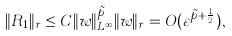Convert formula to latex. <formula><loc_0><loc_0><loc_500><loc_500>\| R _ { 1 } \| _ { \L r } \leq C \| w \| _ { L ^ { \infty } } ^ { \tilde { p } } \| w \| _ { \L r } = O ( \varepsilon ^ { \tilde { p } + \frac { 1 } { 2 } } ) ,</formula> 